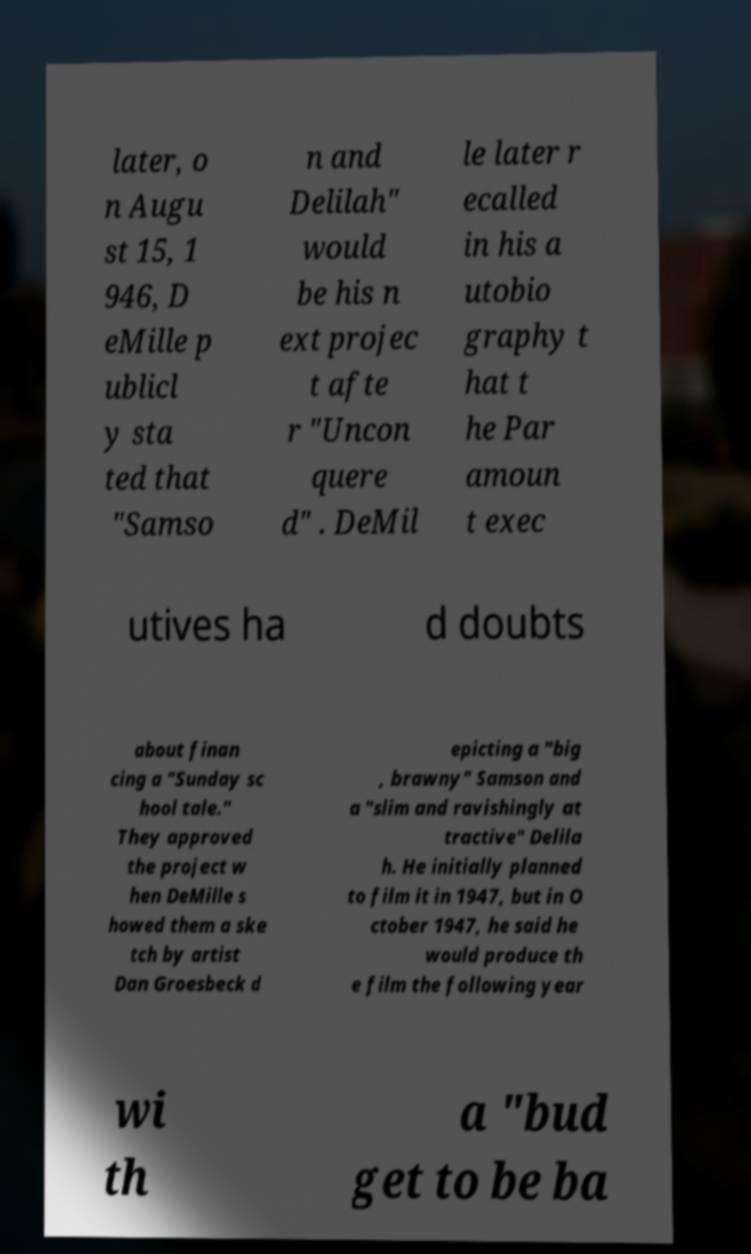For documentation purposes, I need the text within this image transcribed. Could you provide that? later, o n Augu st 15, 1 946, D eMille p ublicl y sta ted that "Samso n and Delilah" would be his n ext projec t afte r "Uncon quere d" . DeMil le later r ecalled in his a utobio graphy t hat t he Par amoun t exec utives ha d doubts about finan cing a "Sunday sc hool tale." They approved the project w hen DeMille s howed them a ske tch by artist Dan Groesbeck d epicting a "big , brawny" Samson and a "slim and ravishingly at tractive" Delila h. He initially planned to film it in 1947, but in O ctober 1947, he said he would produce th e film the following year wi th a "bud get to be ba 